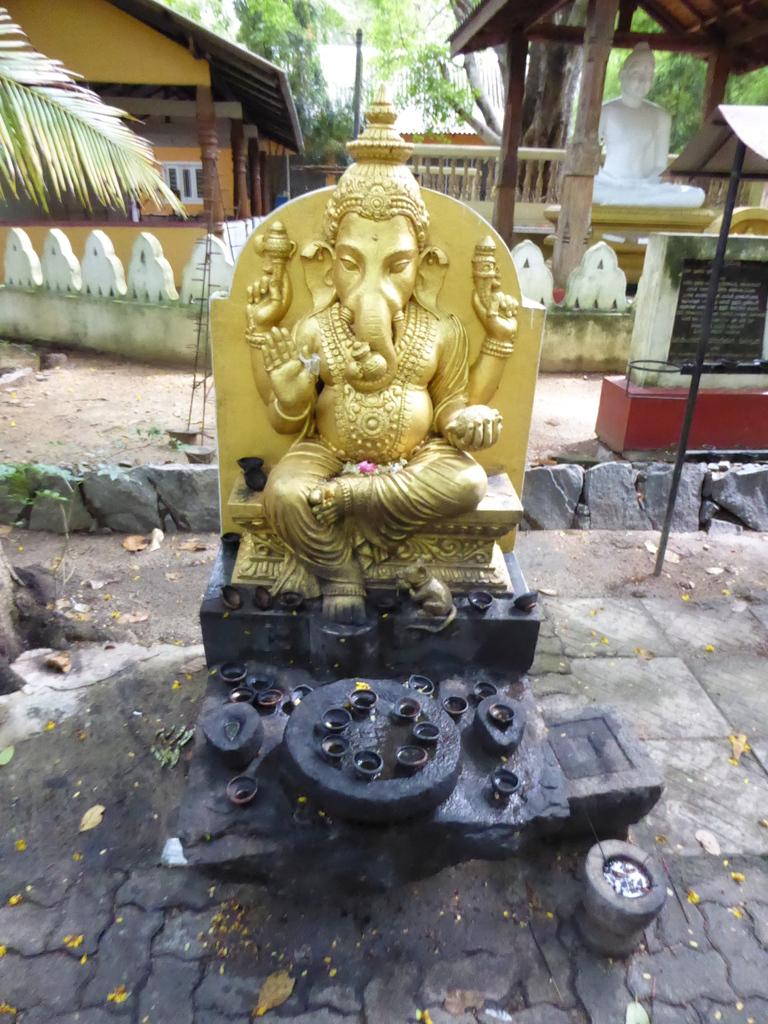What is the main subject of the image? There is a statue of Lord Ganesha in the image. Are there any other objects or features in the image? Yes, there are lamps in the image. What type of grape is hanging from the wall in the image? There is no grape or wall present in the image; it features a statue of Lord Ganesha and lamps. 